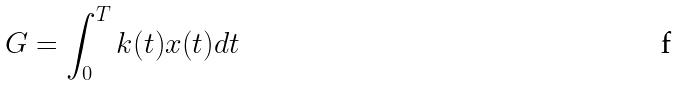Convert formula to latex. <formula><loc_0><loc_0><loc_500><loc_500>G = \int _ { 0 } ^ { T } k ( t ) x ( t ) d t</formula> 